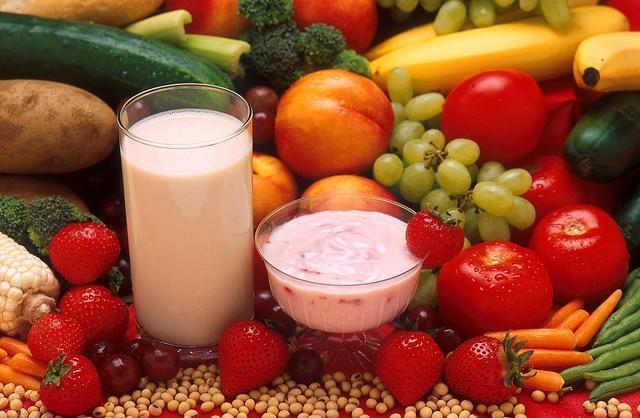How many apples are in the photo?
Give a very brief answer. 2. How many broccolis are there?
Give a very brief answer. 3. 